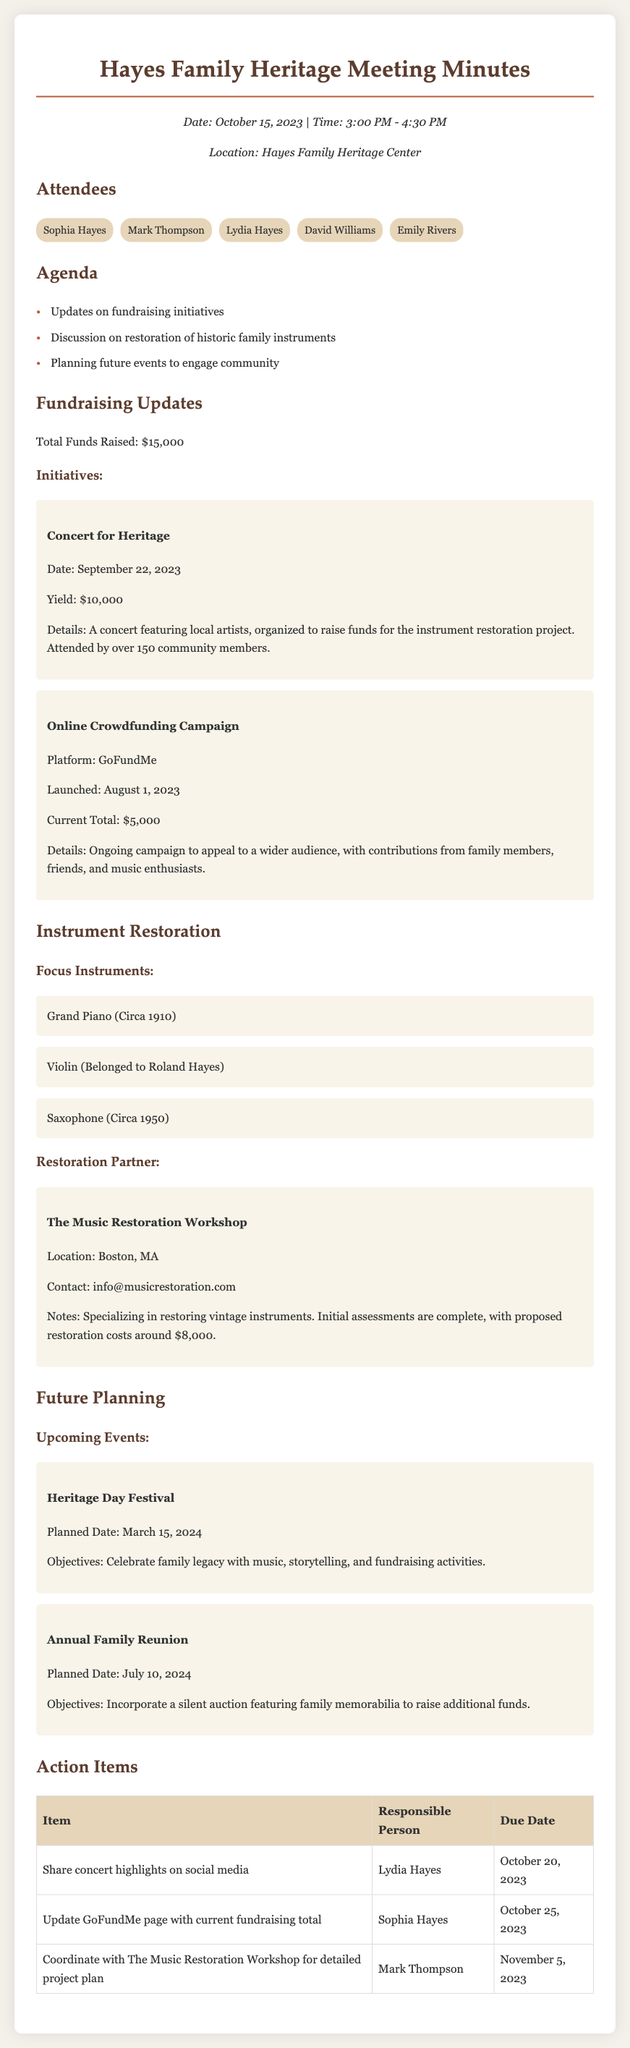What is the total funds raised? The total funds raised is explicitly mentioned in the document as $15,000.
Answer: $15,000 When was the Concert for Heritage held? The document states that the Concert for Heritage took place on September 22, 2023.
Answer: September 22, 2023 What is the planned date for the Heritage Day Festival? The planned date for the Heritage Day Festival is indicated in the document as March 15, 2024.
Answer: March 15, 2024 Who is responsible for sharing concert highlights on social media? The document specifies that Lydia Hayes is tasked with sharing concert highlights on social media.
Answer: Lydia Hayes What is the name of the restoration partner? The name of the restoration partner mentioned in the document is The Music Restoration Workshop.
Answer: The Music Restoration Workshop How much are the proposed restoration costs for the instruments? The proposed restoration costs for the instruments are stated in the document as around $8,000.
Answer: $8,000 What instrument belonged to Roland Hayes? The document mentions that the violin belonged to Roland Hayes.
Answer: Violin What is the objective of the Annual Family Reunion? The objective of the Annual Family Reunion is to incorporate a silent auction featuring family memorabilia to raise additional funds.
Answer: Incorporate a silent auction featuring family memorabilia to raise additional funds 